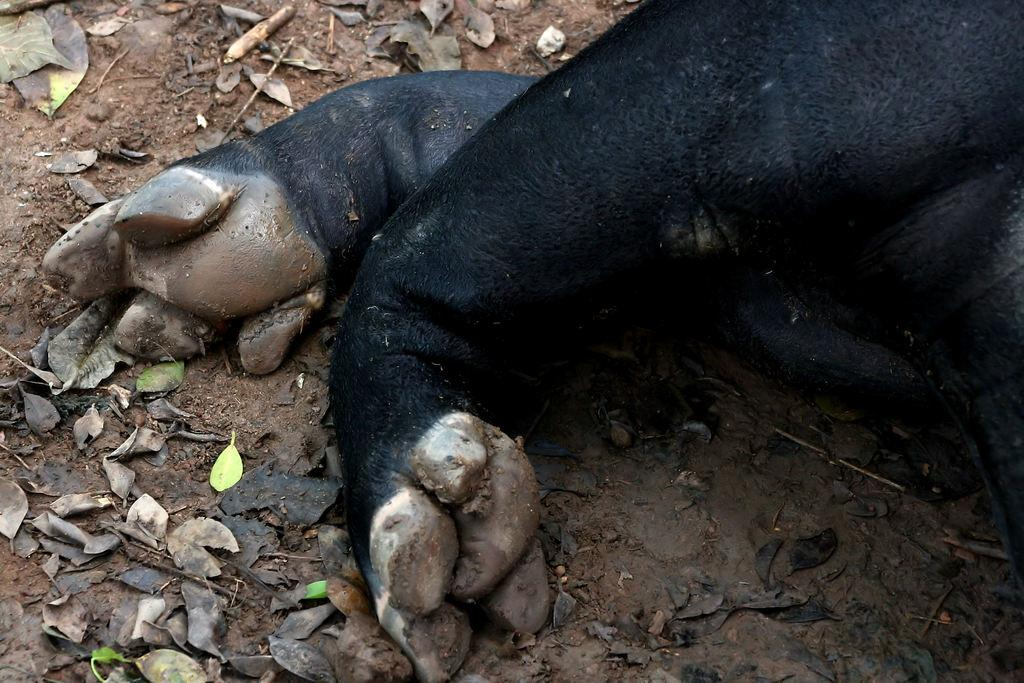What type of body part is visible in the image? The image shows animal legs. What color are the animal legs? The animal legs are black in color. What can be seen on the ground in the image? There are leaves on the ground in the image. Is there a lake visible in the image? No, there is no lake present in the image. What type of wood can be seen in the image? There is no wood visible in the image; it only shows animal legs and leaves on the ground. 